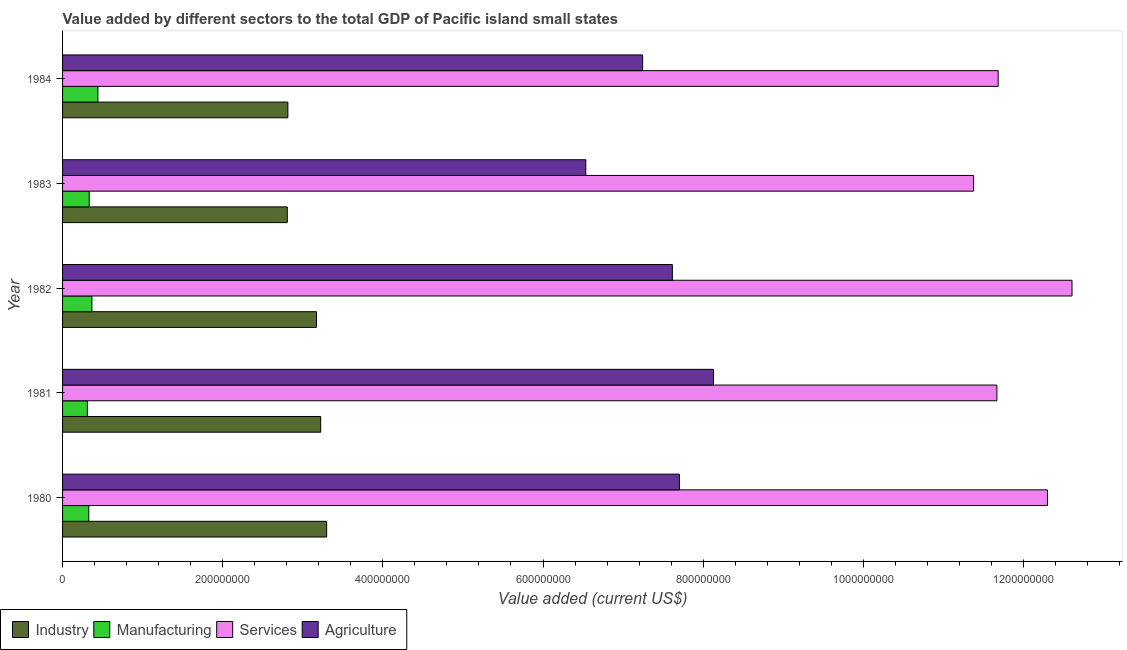How many groups of bars are there?
Your response must be concise. 5. Are the number of bars per tick equal to the number of legend labels?
Ensure brevity in your answer.  Yes. Are the number of bars on each tick of the Y-axis equal?
Your answer should be compact. Yes. How many bars are there on the 2nd tick from the bottom?
Give a very brief answer. 4. What is the value added by industrial sector in 1981?
Your response must be concise. 3.22e+08. Across all years, what is the maximum value added by services sector?
Provide a short and direct response. 1.26e+09. Across all years, what is the minimum value added by manufacturing sector?
Provide a succinct answer. 3.10e+07. In which year was the value added by manufacturing sector maximum?
Keep it short and to the point. 1984. In which year was the value added by services sector minimum?
Keep it short and to the point. 1983. What is the total value added by industrial sector in the graph?
Give a very brief answer. 1.53e+09. What is the difference between the value added by services sector in 1981 and that in 1982?
Offer a terse response. -9.38e+07. What is the difference between the value added by services sector in 1980 and the value added by manufacturing sector in 1982?
Your answer should be compact. 1.19e+09. What is the average value added by agricultural sector per year?
Give a very brief answer. 7.45e+08. In the year 1983, what is the difference between the value added by services sector and value added by agricultural sector?
Offer a very short reply. 4.84e+08. In how many years, is the value added by agricultural sector greater than 800000000 US$?
Your response must be concise. 1. What is the ratio of the value added by agricultural sector in 1982 to that in 1983?
Your response must be concise. 1.17. What is the difference between the highest and the second highest value added by agricultural sector?
Your answer should be compact. 4.26e+07. What is the difference between the highest and the lowest value added by services sector?
Offer a very short reply. 1.23e+08. Is the sum of the value added by agricultural sector in 1980 and 1981 greater than the maximum value added by industrial sector across all years?
Your response must be concise. Yes. What does the 2nd bar from the top in 1984 represents?
Ensure brevity in your answer.  Services. What does the 1st bar from the bottom in 1982 represents?
Provide a short and direct response. Industry. Are the values on the major ticks of X-axis written in scientific E-notation?
Offer a terse response. No. Does the graph contain any zero values?
Give a very brief answer. No. Where does the legend appear in the graph?
Your answer should be very brief. Bottom left. What is the title of the graph?
Offer a terse response. Value added by different sectors to the total GDP of Pacific island small states. Does "Fourth 20% of population" appear as one of the legend labels in the graph?
Offer a terse response. No. What is the label or title of the X-axis?
Provide a succinct answer. Value added (current US$). What is the label or title of the Y-axis?
Your answer should be compact. Year. What is the Value added (current US$) in Industry in 1980?
Make the answer very short. 3.30e+08. What is the Value added (current US$) of Manufacturing in 1980?
Your response must be concise. 3.27e+07. What is the Value added (current US$) of Services in 1980?
Make the answer very short. 1.23e+09. What is the Value added (current US$) of Agriculture in 1980?
Give a very brief answer. 7.70e+08. What is the Value added (current US$) in Industry in 1981?
Your response must be concise. 3.22e+08. What is the Value added (current US$) of Manufacturing in 1981?
Provide a succinct answer. 3.10e+07. What is the Value added (current US$) of Services in 1981?
Your answer should be compact. 1.17e+09. What is the Value added (current US$) of Agriculture in 1981?
Provide a succinct answer. 8.13e+08. What is the Value added (current US$) in Industry in 1982?
Keep it short and to the point. 3.17e+08. What is the Value added (current US$) of Manufacturing in 1982?
Your answer should be compact. 3.66e+07. What is the Value added (current US$) in Services in 1982?
Give a very brief answer. 1.26e+09. What is the Value added (current US$) in Agriculture in 1982?
Make the answer very short. 7.62e+08. What is the Value added (current US$) of Industry in 1983?
Your answer should be very brief. 2.81e+08. What is the Value added (current US$) of Manufacturing in 1983?
Your answer should be very brief. 3.33e+07. What is the Value added (current US$) of Services in 1983?
Provide a short and direct response. 1.14e+09. What is the Value added (current US$) in Agriculture in 1983?
Your answer should be compact. 6.53e+08. What is the Value added (current US$) of Industry in 1984?
Your answer should be very brief. 2.81e+08. What is the Value added (current US$) in Manufacturing in 1984?
Ensure brevity in your answer.  4.41e+07. What is the Value added (current US$) of Services in 1984?
Give a very brief answer. 1.17e+09. What is the Value added (current US$) of Agriculture in 1984?
Offer a very short reply. 7.24e+08. Across all years, what is the maximum Value added (current US$) in Industry?
Keep it short and to the point. 3.30e+08. Across all years, what is the maximum Value added (current US$) of Manufacturing?
Offer a very short reply. 4.41e+07. Across all years, what is the maximum Value added (current US$) in Services?
Offer a terse response. 1.26e+09. Across all years, what is the maximum Value added (current US$) of Agriculture?
Keep it short and to the point. 8.13e+08. Across all years, what is the minimum Value added (current US$) of Industry?
Your response must be concise. 2.81e+08. Across all years, what is the minimum Value added (current US$) in Manufacturing?
Provide a short and direct response. 3.10e+07. Across all years, what is the minimum Value added (current US$) in Services?
Your answer should be compact. 1.14e+09. Across all years, what is the minimum Value added (current US$) of Agriculture?
Ensure brevity in your answer.  6.53e+08. What is the total Value added (current US$) in Industry in the graph?
Your response must be concise. 1.53e+09. What is the total Value added (current US$) in Manufacturing in the graph?
Make the answer very short. 1.78e+08. What is the total Value added (current US$) of Services in the graph?
Provide a succinct answer. 5.96e+09. What is the total Value added (current US$) of Agriculture in the graph?
Keep it short and to the point. 3.72e+09. What is the difference between the Value added (current US$) in Industry in 1980 and that in 1981?
Ensure brevity in your answer.  7.42e+06. What is the difference between the Value added (current US$) of Manufacturing in 1980 and that in 1981?
Keep it short and to the point. 1.74e+06. What is the difference between the Value added (current US$) in Services in 1980 and that in 1981?
Provide a succinct answer. 6.31e+07. What is the difference between the Value added (current US$) of Agriculture in 1980 and that in 1981?
Your answer should be compact. -4.26e+07. What is the difference between the Value added (current US$) of Industry in 1980 and that in 1982?
Ensure brevity in your answer.  1.27e+07. What is the difference between the Value added (current US$) of Manufacturing in 1980 and that in 1982?
Provide a succinct answer. -3.90e+06. What is the difference between the Value added (current US$) in Services in 1980 and that in 1982?
Your answer should be very brief. -3.07e+07. What is the difference between the Value added (current US$) of Agriculture in 1980 and that in 1982?
Make the answer very short. 8.78e+06. What is the difference between the Value added (current US$) in Industry in 1980 and that in 1983?
Provide a succinct answer. 4.92e+07. What is the difference between the Value added (current US$) in Manufacturing in 1980 and that in 1983?
Offer a very short reply. -5.31e+05. What is the difference between the Value added (current US$) in Services in 1980 and that in 1983?
Provide a succinct answer. 9.23e+07. What is the difference between the Value added (current US$) of Agriculture in 1980 and that in 1983?
Your answer should be compact. 1.17e+08. What is the difference between the Value added (current US$) in Industry in 1980 and that in 1984?
Your response must be concise. 4.84e+07. What is the difference between the Value added (current US$) in Manufacturing in 1980 and that in 1984?
Give a very brief answer. -1.14e+07. What is the difference between the Value added (current US$) of Services in 1980 and that in 1984?
Provide a short and direct response. 6.15e+07. What is the difference between the Value added (current US$) in Agriculture in 1980 and that in 1984?
Provide a short and direct response. 4.59e+07. What is the difference between the Value added (current US$) of Industry in 1981 and that in 1982?
Offer a terse response. 5.26e+06. What is the difference between the Value added (current US$) in Manufacturing in 1981 and that in 1982?
Offer a very short reply. -5.64e+06. What is the difference between the Value added (current US$) of Services in 1981 and that in 1982?
Give a very brief answer. -9.38e+07. What is the difference between the Value added (current US$) in Agriculture in 1981 and that in 1982?
Your response must be concise. 5.13e+07. What is the difference between the Value added (current US$) of Industry in 1981 and that in 1983?
Ensure brevity in your answer.  4.17e+07. What is the difference between the Value added (current US$) of Manufacturing in 1981 and that in 1983?
Provide a short and direct response. -2.27e+06. What is the difference between the Value added (current US$) of Services in 1981 and that in 1983?
Ensure brevity in your answer.  2.92e+07. What is the difference between the Value added (current US$) of Agriculture in 1981 and that in 1983?
Give a very brief answer. 1.59e+08. What is the difference between the Value added (current US$) of Industry in 1981 and that in 1984?
Make the answer very short. 4.10e+07. What is the difference between the Value added (current US$) of Manufacturing in 1981 and that in 1984?
Ensure brevity in your answer.  -1.31e+07. What is the difference between the Value added (current US$) of Services in 1981 and that in 1984?
Offer a terse response. -1.59e+06. What is the difference between the Value added (current US$) in Agriculture in 1981 and that in 1984?
Offer a terse response. 8.85e+07. What is the difference between the Value added (current US$) of Industry in 1982 and that in 1983?
Keep it short and to the point. 3.65e+07. What is the difference between the Value added (current US$) in Manufacturing in 1982 and that in 1983?
Make the answer very short. 3.37e+06. What is the difference between the Value added (current US$) of Services in 1982 and that in 1983?
Give a very brief answer. 1.23e+08. What is the difference between the Value added (current US$) in Agriculture in 1982 and that in 1983?
Your response must be concise. 1.08e+08. What is the difference between the Value added (current US$) in Industry in 1982 and that in 1984?
Your answer should be very brief. 3.57e+07. What is the difference between the Value added (current US$) in Manufacturing in 1982 and that in 1984?
Your response must be concise. -7.48e+06. What is the difference between the Value added (current US$) of Services in 1982 and that in 1984?
Your answer should be compact. 9.22e+07. What is the difference between the Value added (current US$) of Agriculture in 1982 and that in 1984?
Make the answer very short. 3.71e+07. What is the difference between the Value added (current US$) in Industry in 1983 and that in 1984?
Make the answer very short. -7.46e+05. What is the difference between the Value added (current US$) in Manufacturing in 1983 and that in 1984?
Your response must be concise. -1.09e+07. What is the difference between the Value added (current US$) of Services in 1983 and that in 1984?
Your answer should be very brief. -3.07e+07. What is the difference between the Value added (current US$) in Agriculture in 1983 and that in 1984?
Offer a very short reply. -7.09e+07. What is the difference between the Value added (current US$) of Industry in 1980 and the Value added (current US$) of Manufacturing in 1981?
Offer a very short reply. 2.99e+08. What is the difference between the Value added (current US$) of Industry in 1980 and the Value added (current US$) of Services in 1981?
Offer a very short reply. -8.37e+08. What is the difference between the Value added (current US$) of Industry in 1980 and the Value added (current US$) of Agriculture in 1981?
Offer a terse response. -4.83e+08. What is the difference between the Value added (current US$) in Manufacturing in 1980 and the Value added (current US$) in Services in 1981?
Your answer should be very brief. -1.13e+09. What is the difference between the Value added (current US$) of Manufacturing in 1980 and the Value added (current US$) of Agriculture in 1981?
Ensure brevity in your answer.  -7.80e+08. What is the difference between the Value added (current US$) of Services in 1980 and the Value added (current US$) of Agriculture in 1981?
Your response must be concise. 4.17e+08. What is the difference between the Value added (current US$) in Industry in 1980 and the Value added (current US$) in Manufacturing in 1982?
Provide a short and direct response. 2.93e+08. What is the difference between the Value added (current US$) in Industry in 1980 and the Value added (current US$) in Services in 1982?
Provide a succinct answer. -9.31e+08. What is the difference between the Value added (current US$) of Industry in 1980 and the Value added (current US$) of Agriculture in 1982?
Your response must be concise. -4.32e+08. What is the difference between the Value added (current US$) of Manufacturing in 1980 and the Value added (current US$) of Services in 1982?
Offer a terse response. -1.23e+09. What is the difference between the Value added (current US$) of Manufacturing in 1980 and the Value added (current US$) of Agriculture in 1982?
Offer a very short reply. -7.29e+08. What is the difference between the Value added (current US$) in Services in 1980 and the Value added (current US$) in Agriculture in 1982?
Your answer should be compact. 4.68e+08. What is the difference between the Value added (current US$) in Industry in 1980 and the Value added (current US$) in Manufacturing in 1983?
Give a very brief answer. 2.97e+08. What is the difference between the Value added (current US$) of Industry in 1980 and the Value added (current US$) of Services in 1983?
Ensure brevity in your answer.  -8.08e+08. What is the difference between the Value added (current US$) of Industry in 1980 and the Value added (current US$) of Agriculture in 1983?
Keep it short and to the point. -3.24e+08. What is the difference between the Value added (current US$) of Manufacturing in 1980 and the Value added (current US$) of Services in 1983?
Give a very brief answer. -1.10e+09. What is the difference between the Value added (current US$) in Manufacturing in 1980 and the Value added (current US$) in Agriculture in 1983?
Offer a terse response. -6.21e+08. What is the difference between the Value added (current US$) of Services in 1980 and the Value added (current US$) of Agriculture in 1983?
Keep it short and to the point. 5.77e+08. What is the difference between the Value added (current US$) of Industry in 1980 and the Value added (current US$) of Manufacturing in 1984?
Offer a terse response. 2.86e+08. What is the difference between the Value added (current US$) of Industry in 1980 and the Value added (current US$) of Services in 1984?
Make the answer very short. -8.39e+08. What is the difference between the Value added (current US$) of Industry in 1980 and the Value added (current US$) of Agriculture in 1984?
Give a very brief answer. -3.95e+08. What is the difference between the Value added (current US$) in Manufacturing in 1980 and the Value added (current US$) in Services in 1984?
Your answer should be very brief. -1.14e+09. What is the difference between the Value added (current US$) in Manufacturing in 1980 and the Value added (current US$) in Agriculture in 1984?
Offer a very short reply. -6.92e+08. What is the difference between the Value added (current US$) in Services in 1980 and the Value added (current US$) in Agriculture in 1984?
Make the answer very short. 5.06e+08. What is the difference between the Value added (current US$) in Industry in 1981 and the Value added (current US$) in Manufacturing in 1982?
Your answer should be compact. 2.86e+08. What is the difference between the Value added (current US$) in Industry in 1981 and the Value added (current US$) in Services in 1982?
Your answer should be very brief. -9.38e+08. What is the difference between the Value added (current US$) in Industry in 1981 and the Value added (current US$) in Agriculture in 1982?
Provide a short and direct response. -4.39e+08. What is the difference between the Value added (current US$) of Manufacturing in 1981 and the Value added (current US$) of Services in 1982?
Make the answer very short. -1.23e+09. What is the difference between the Value added (current US$) in Manufacturing in 1981 and the Value added (current US$) in Agriculture in 1982?
Your answer should be compact. -7.31e+08. What is the difference between the Value added (current US$) in Services in 1981 and the Value added (current US$) in Agriculture in 1982?
Make the answer very short. 4.05e+08. What is the difference between the Value added (current US$) in Industry in 1981 and the Value added (current US$) in Manufacturing in 1983?
Ensure brevity in your answer.  2.89e+08. What is the difference between the Value added (current US$) in Industry in 1981 and the Value added (current US$) in Services in 1983?
Provide a succinct answer. -8.15e+08. What is the difference between the Value added (current US$) in Industry in 1981 and the Value added (current US$) in Agriculture in 1983?
Ensure brevity in your answer.  -3.31e+08. What is the difference between the Value added (current US$) in Manufacturing in 1981 and the Value added (current US$) in Services in 1983?
Your response must be concise. -1.11e+09. What is the difference between the Value added (current US$) of Manufacturing in 1981 and the Value added (current US$) of Agriculture in 1983?
Provide a succinct answer. -6.22e+08. What is the difference between the Value added (current US$) in Services in 1981 and the Value added (current US$) in Agriculture in 1983?
Your answer should be very brief. 5.13e+08. What is the difference between the Value added (current US$) of Industry in 1981 and the Value added (current US$) of Manufacturing in 1984?
Your response must be concise. 2.78e+08. What is the difference between the Value added (current US$) in Industry in 1981 and the Value added (current US$) in Services in 1984?
Your answer should be compact. -8.46e+08. What is the difference between the Value added (current US$) in Industry in 1981 and the Value added (current US$) in Agriculture in 1984?
Offer a terse response. -4.02e+08. What is the difference between the Value added (current US$) in Manufacturing in 1981 and the Value added (current US$) in Services in 1984?
Give a very brief answer. -1.14e+09. What is the difference between the Value added (current US$) of Manufacturing in 1981 and the Value added (current US$) of Agriculture in 1984?
Give a very brief answer. -6.93e+08. What is the difference between the Value added (current US$) of Services in 1981 and the Value added (current US$) of Agriculture in 1984?
Ensure brevity in your answer.  4.42e+08. What is the difference between the Value added (current US$) in Industry in 1982 and the Value added (current US$) in Manufacturing in 1983?
Offer a very short reply. 2.84e+08. What is the difference between the Value added (current US$) in Industry in 1982 and the Value added (current US$) in Services in 1983?
Provide a succinct answer. -8.21e+08. What is the difference between the Value added (current US$) of Industry in 1982 and the Value added (current US$) of Agriculture in 1983?
Provide a succinct answer. -3.36e+08. What is the difference between the Value added (current US$) of Manufacturing in 1982 and the Value added (current US$) of Services in 1983?
Provide a short and direct response. -1.10e+09. What is the difference between the Value added (current US$) in Manufacturing in 1982 and the Value added (current US$) in Agriculture in 1983?
Offer a very short reply. -6.17e+08. What is the difference between the Value added (current US$) of Services in 1982 and the Value added (current US$) of Agriculture in 1983?
Keep it short and to the point. 6.07e+08. What is the difference between the Value added (current US$) in Industry in 1982 and the Value added (current US$) in Manufacturing in 1984?
Give a very brief answer. 2.73e+08. What is the difference between the Value added (current US$) in Industry in 1982 and the Value added (current US$) in Services in 1984?
Give a very brief answer. -8.51e+08. What is the difference between the Value added (current US$) in Industry in 1982 and the Value added (current US$) in Agriculture in 1984?
Offer a terse response. -4.07e+08. What is the difference between the Value added (current US$) in Manufacturing in 1982 and the Value added (current US$) in Services in 1984?
Offer a very short reply. -1.13e+09. What is the difference between the Value added (current US$) of Manufacturing in 1982 and the Value added (current US$) of Agriculture in 1984?
Offer a terse response. -6.88e+08. What is the difference between the Value added (current US$) of Services in 1982 and the Value added (current US$) of Agriculture in 1984?
Your response must be concise. 5.36e+08. What is the difference between the Value added (current US$) of Industry in 1983 and the Value added (current US$) of Manufacturing in 1984?
Provide a succinct answer. 2.37e+08. What is the difference between the Value added (current US$) in Industry in 1983 and the Value added (current US$) in Services in 1984?
Ensure brevity in your answer.  -8.88e+08. What is the difference between the Value added (current US$) in Industry in 1983 and the Value added (current US$) in Agriculture in 1984?
Your answer should be compact. -4.44e+08. What is the difference between the Value added (current US$) of Manufacturing in 1983 and the Value added (current US$) of Services in 1984?
Ensure brevity in your answer.  -1.14e+09. What is the difference between the Value added (current US$) of Manufacturing in 1983 and the Value added (current US$) of Agriculture in 1984?
Ensure brevity in your answer.  -6.91e+08. What is the difference between the Value added (current US$) in Services in 1983 and the Value added (current US$) in Agriculture in 1984?
Provide a succinct answer. 4.13e+08. What is the average Value added (current US$) in Industry per year?
Provide a short and direct response. 3.06e+08. What is the average Value added (current US$) of Manufacturing per year?
Your response must be concise. 3.55e+07. What is the average Value added (current US$) in Services per year?
Ensure brevity in your answer.  1.19e+09. What is the average Value added (current US$) of Agriculture per year?
Your answer should be compact. 7.45e+08. In the year 1980, what is the difference between the Value added (current US$) in Industry and Value added (current US$) in Manufacturing?
Ensure brevity in your answer.  2.97e+08. In the year 1980, what is the difference between the Value added (current US$) of Industry and Value added (current US$) of Services?
Provide a short and direct response. -9.00e+08. In the year 1980, what is the difference between the Value added (current US$) in Industry and Value added (current US$) in Agriculture?
Offer a terse response. -4.41e+08. In the year 1980, what is the difference between the Value added (current US$) of Manufacturing and Value added (current US$) of Services?
Offer a very short reply. -1.20e+09. In the year 1980, what is the difference between the Value added (current US$) in Manufacturing and Value added (current US$) in Agriculture?
Keep it short and to the point. -7.38e+08. In the year 1980, what is the difference between the Value added (current US$) of Services and Value added (current US$) of Agriculture?
Your answer should be very brief. 4.60e+08. In the year 1981, what is the difference between the Value added (current US$) in Industry and Value added (current US$) in Manufacturing?
Keep it short and to the point. 2.91e+08. In the year 1981, what is the difference between the Value added (current US$) of Industry and Value added (current US$) of Services?
Provide a short and direct response. -8.44e+08. In the year 1981, what is the difference between the Value added (current US$) of Industry and Value added (current US$) of Agriculture?
Offer a terse response. -4.90e+08. In the year 1981, what is the difference between the Value added (current US$) in Manufacturing and Value added (current US$) in Services?
Ensure brevity in your answer.  -1.14e+09. In the year 1981, what is the difference between the Value added (current US$) of Manufacturing and Value added (current US$) of Agriculture?
Make the answer very short. -7.82e+08. In the year 1981, what is the difference between the Value added (current US$) in Services and Value added (current US$) in Agriculture?
Offer a very short reply. 3.54e+08. In the year 1982, what is the difference between the Value added (current US$) of Industry and Value added (current US$) of Manufacturing?
Provide a succinct answer. 2.80e+08. In the year 1982, what is the difference between the Value added (current US$) of Industry and Value added (current US$) of Services?
Give a very brief answer. -9.44e+08. In the year 1982, what is the difference between the Value added (current US$) in Industry and Value added (current US$) in Agriculture?
Offer a very short reply. -4.44e+08. In the year 1982, what is the difference between the Value added (current US$) in Manufacturing and Value added (current US$) in Services?
Provide a short and direct response. -1.22e+09. In the year 1982, what is the difference between the Value added (current US$) of Manufacturing and Value added (current US$) of Agriculture?
Provide a succinct answer. -7.25e+08. In the year 1982, what is the difference between the Value added (current US$) in Services and Value added (current US$) in Agriculture?
Make the answer very short. 4.99e+08. In the year 1983, what is the difference between the Value added (current US$) of Industry and Value added (current US$) of Manufacturing?
Offer a terse response. 2.47e+08. In the year 1983, what is the difference between the Value added (current US$) of Industry and Value added (current US$) of Services?
Provide a succinct answer. -8.57e+08. In the year 1983, what is the difference between the Value added (current US$) of Industry and Value added (current US$) of Agriculture?
Your answer should be compact. -3.73e+08. In the year 1983, what is the difference between the Value added (current US$) in Manufacturing and Value added (current US$) in Services?
Make the answer very short. -1.10e+09. In the year 1983, what is the difference between the Value added (current US$) of Manufacturing and Value added (current US$) of Agriculture?
Make the answer very short. -6.20e+08. In the year 1983, what is the difference between the Value added (current US$) of Services and Value added (current US$) of Agriculture?
Your response must be concise. 4.84e+08. In the year 1984, what is the difference between the Value added (current US$) of Industry and Value added (current US$) of Manufacturing?
Provide a short and direct response. 2.37e+08. In the year 1984, what is the difference between the Value added (current US$) of Industry and Value added (current US$) of Services?
Give a very brief answer. -8.87e+08. In the year 1984, what is the difference between the Value added (current US$) in Industry and Value added (current US$) in Agriculture?
Keep it short and to the point. -4.43e+08. In the year 1984, what is the difference between the Value added (current US$) of Manufacturing and Value added (current US$) of Services?
Give a very brief answer. -1.12e+09. In the year 1984, what is the difference between the Value added (current US$) of Manufacturing and Value added (current US$) of Agriculture?
Your answer should be very brief. -6.80e+08. In the year 1984, what is the difference between the Value added (current US$) in Services and Value added (current US$) in Agriculture?
Your answer should be compact. 4.44e+08. What is the ratio of the Value added (current US$) of Manufacturing in 1980 to that in 1981?
Make the answer very short. 1.06. What is the ratio of the Value added (current US$) in Services in 1980 to that in 1981?
Keep it short and to the point. 1.05. What is the ratio of the Value added (current US$) in Agriculture in 1980 to that in 1981?
Provide a short and direct response. 0.95. What is the ratio of the Value added (current US$) of Manufacturing in 1980 to that in 1982?
Provide a short and direct response. 0.89. What is the ratio of the Value added (current US$) of Services in 1980 to that in 1982?
Give a very brief answer. 0.98. What is the ratio of the Value added (current US$) of Agriculture in 1980 to that in 1982?
Your answer should be compact. 1.01. What is the ratio of the Value added (current US$) of Industry in 1980 to that in 1983?
Offer a terse response. 1.18. What is the ratio of the Value added (current US$) of Services in 1980 to that in 1983?
Give a very brief answer. 1.08. What is the ratio of the Value added (current US$) in Agriculture in 1980 to that in 1983?
Ensure brevity in your answer.  1.18. What is the ratio of the Value added (current US$) of Industry in 1980 to that in 1984?
Make the answer very short. 1.17. What is the ratio of the Value added (current US$) in Manufacturing in 1980 to that in 1984?
Give a very brief answer. 0.74. What is the ratio of the Value added (current US$) of Services in 1980 to that in 1984?
Offer a terse response. 1.05. What is the ratio of the Value added (current US$) in Agriculture in 1980 to that in 1984?
Your response must be concise. 1.06. What is the ratio of the Value added (current US$) of Industry in 1981 to that in 1982?
Make the answer very short. 1.02. What is the ratio of the Value added (current US$) of Manufacturing in 1981 to that in 1982?
Keep it short and to the point. 0.85. What is the ratio of the Value added (current US$) of Services in 1981 to that in 1982?
Offer a very short reply. 0.93. What is the ratio of the Value added (current US$) in Agriculture in 1981 to that in 1982?
Offer a terse response. 1.07. What is the ratio of the Value added (current US$) of Industry in 1981 to that in 1983?
Ensure brevity in your answer.  1.15. What is the ratio of the Value added (current US$) of Manufacturing in 1981 to that in 1983?
Your answer should be very brief. 0.93. What is the ratio of the Value added (current US$) in Services in 1981 to that in 1983?
Your answer should be compact. 1.03. What is the ratio of the Value added (current US$) in Agriculture in 1981 to that in 1983?
Give a very brief answer. 1.24. What is the ratio of the Value added (current US$) of Industry in 1981 to that in 1984?
Your answer should be very brief. 1.15. What is the ratio of the Value added (current US$) of Manufacturing in 1981 to that in 1984?
Your answer should be compact. 0.7. What is the ratio of the Value added (current US$) of Services in 1981 to that in 1984?
Offer a very short reply. 1. What is the ratio of the Value added (current US$) in Agriculture in 1981 to that in 1984?
Make the answer very short. 1.12. What is the ratio of the Value added (current US$) in Industry in 1982 to that in 1983?
Offer a very short reply. 1.13. What is the ratio of the Value added (current US$) of Manufacturing in 1982 to that in 1983?
Make the answer very short. 1.1. What is the ratio of the Value added (current US$) in Services in 1982 to that in 1983?
Your answer should be very brief. 1.11. What is the ratio of the Value added (current US$) of Agriculture in 1982 to that in 1983?
Provide a succinct answer. 1.17. What is the ratio of the Value added (current US$) of Industry in 1982 to that in 1984?
Make the answer very short. 1.13. What is the ratio of the Value added (current US$) of Manufacturing in 1982 to that in 1984?
Give a very brief answer. 0.83. What is the ratio of the Value added (current US$) in Services in 1982 to that in 1984?
Offer a very short reply. 1.08. What is the ratio of the Value added (current US$) in Agriculture in 1982 to that in 1984?
Provide a short and direct response. 1.05. What is the ratio of the Value added (current US$) of Industry in 1983 to that in 1984?
Your answer should be compact. 1. What is the ratio of the Value added (current US$) of Manufacturing in 1983 to that in 1984?
Offer a very short reply. 0.75. What is the ratio of the Value added (current US$) in Services in 1983 to that in 1984?
Provide a succinct answer. 0.97. What is the ratio of the Value added (current US$) of Agriculture in 1983 to that in 1984?
Your answer should be very brief. 0.9. What is the difference between the highest and the second highest Value added (current US$) of Industry?
Provide a short and direct response. 7.42e+06. What is the difference between the highest and the second highest Value added (current US$) in Manufacturing?
Keep it short and to the point. 7.48e+06. What is the difference between the highest and the second highest Value added (current US$) in Services?
Provide a succinct answer. 3.07e+07. What is the difference between the highest and the second highest Value added (current US$) of Agriculture?
Keep it short and to the point. 4.26e+07. What is the difference between the highest and the lowest Value added (current US$) in Industry?
Provide a short and direct response. 4.92e+07. What is the difference between the highest and the lowest Value added (current US$) of Manufacturing?
Make the answer very short. 1.31e+07. What is the difference between the highest and the lowest Value added (current US$) in Services?
Ensure brevity in your answer.  1.23e+08. What is the difference between the highest and the lowest Value added (current US$) in Agriculture?
Your response must be concise. 1.59e+08. 